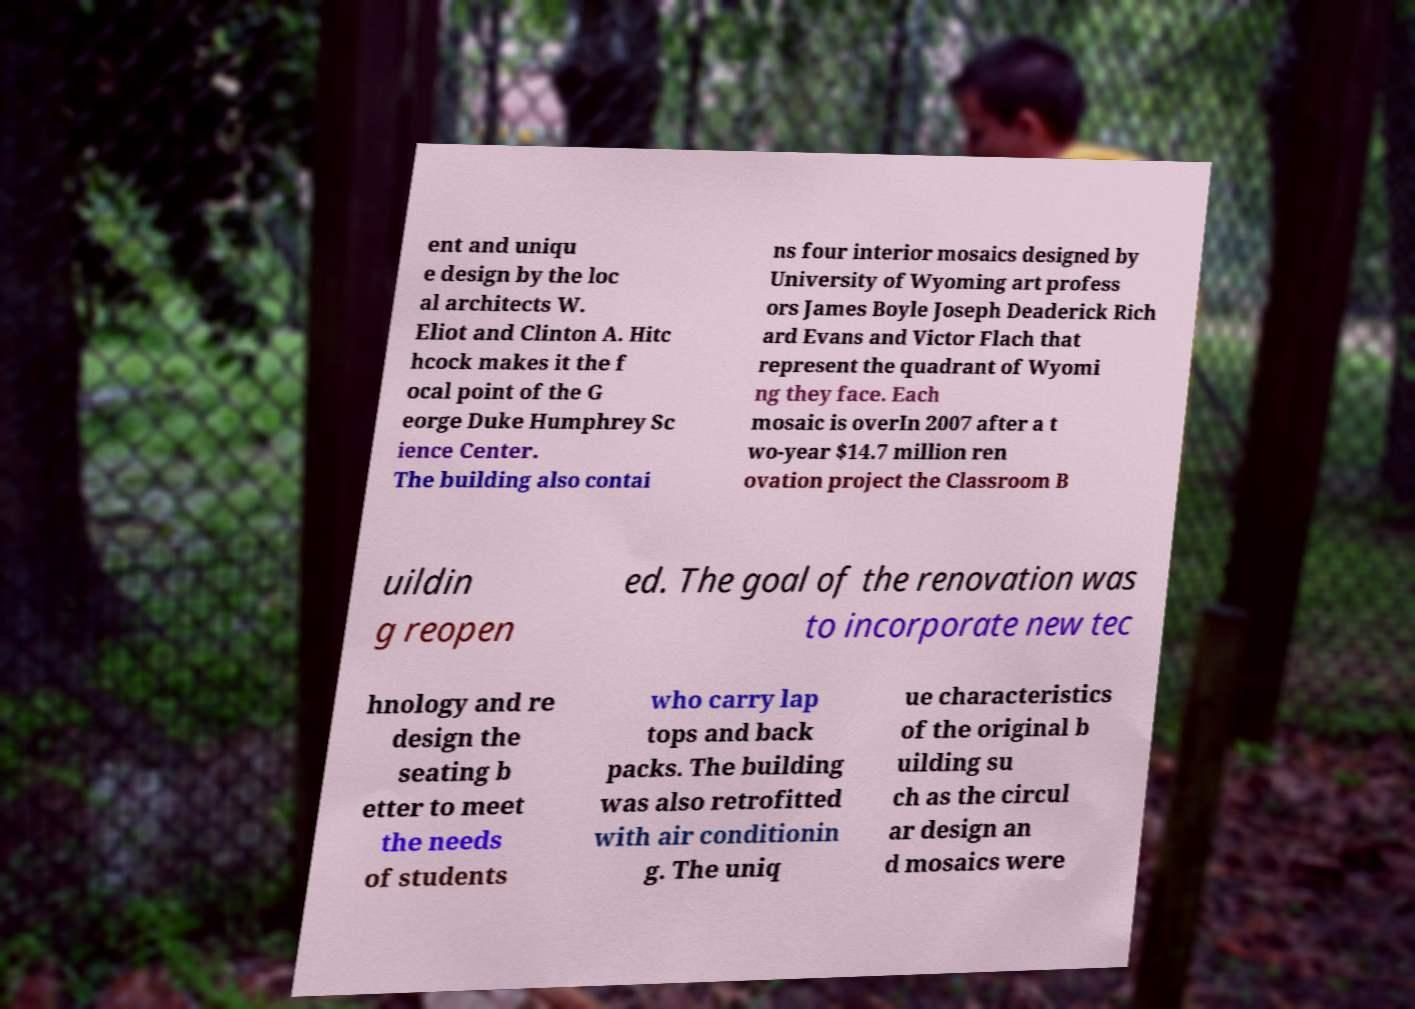Please identify and transcribe the text found in this image. ent and uniqu e design by the loc al architects W. Eliot and Clinton A. Hitc hcock makes it the f ocal point of the G eorge Duke Humphrey Sc ience Center. The building also contai ns four interior mosaics designed by University of Wyoming art profess ors James Boyle Joseph Deaderick Rich ard Evans and Victor Flach that represent the quadrant of Wyomi ng they face. Each mosaic is overIn 2007 after a t wo-year $14.7 million ren ovation project the Classroom B uildin g reopen ed. The goal of the renovation was to incorporate new tec hnology and re design the seating b etter to meet the needs of students who carry lap tops and back packs. The building was also retrofitted with air conditionin g. The uniq ue characteristics of the original b uilding su ch as the circul ar design an d mosaics were 